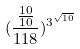Convert formula to latex. <formula><loc_0><loc_0><loc_500><loc_500>( \frac { \frac { 1 0 } { 1 0 } } { 1 1 8 } ) ^ { 3 ^ { \sqrt { 1 0 } } }</formula> 